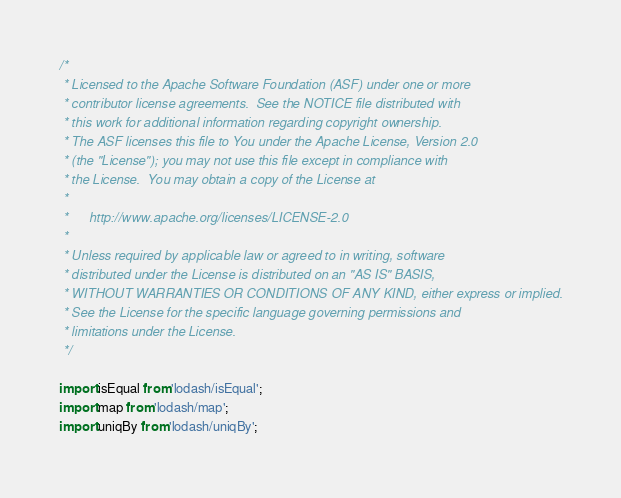Convert code to text. <code><loc_0><loc_0><loc_500><loc_500><_JavaScript_>/*
 * Licensed to the Apache Software Foundation (ASF) under one or more
 * contributor license agreements.  See the NOTICE file distributed with
 * this work for additional information regarding copyright ownership.
 * The ASF licenses this file to You under the Apache License, Version 2.0
 * (the "License"); you may not use this file except in compliance with
 * the License.  You may obtain a copy of the License at
 *
 *      http://www.apache.org/licenses/LICENSE-2.0
 *
 * Unless required by applicable law or agreed to in writing, software
 * distributed under the License is distributed on an "AS IS" BASIS,
 * WITHOUT WARRANTIES OR CONDITIONS OF ANY KIND, either express or implied.
 * See the License for the specific language governing permissions and
 * limitations under the License.
 */

import isEqual from 'lodash/isEqual';
import map from 'lodash/map';
import uniqBy from 'lodash/uniqBy';</code> 